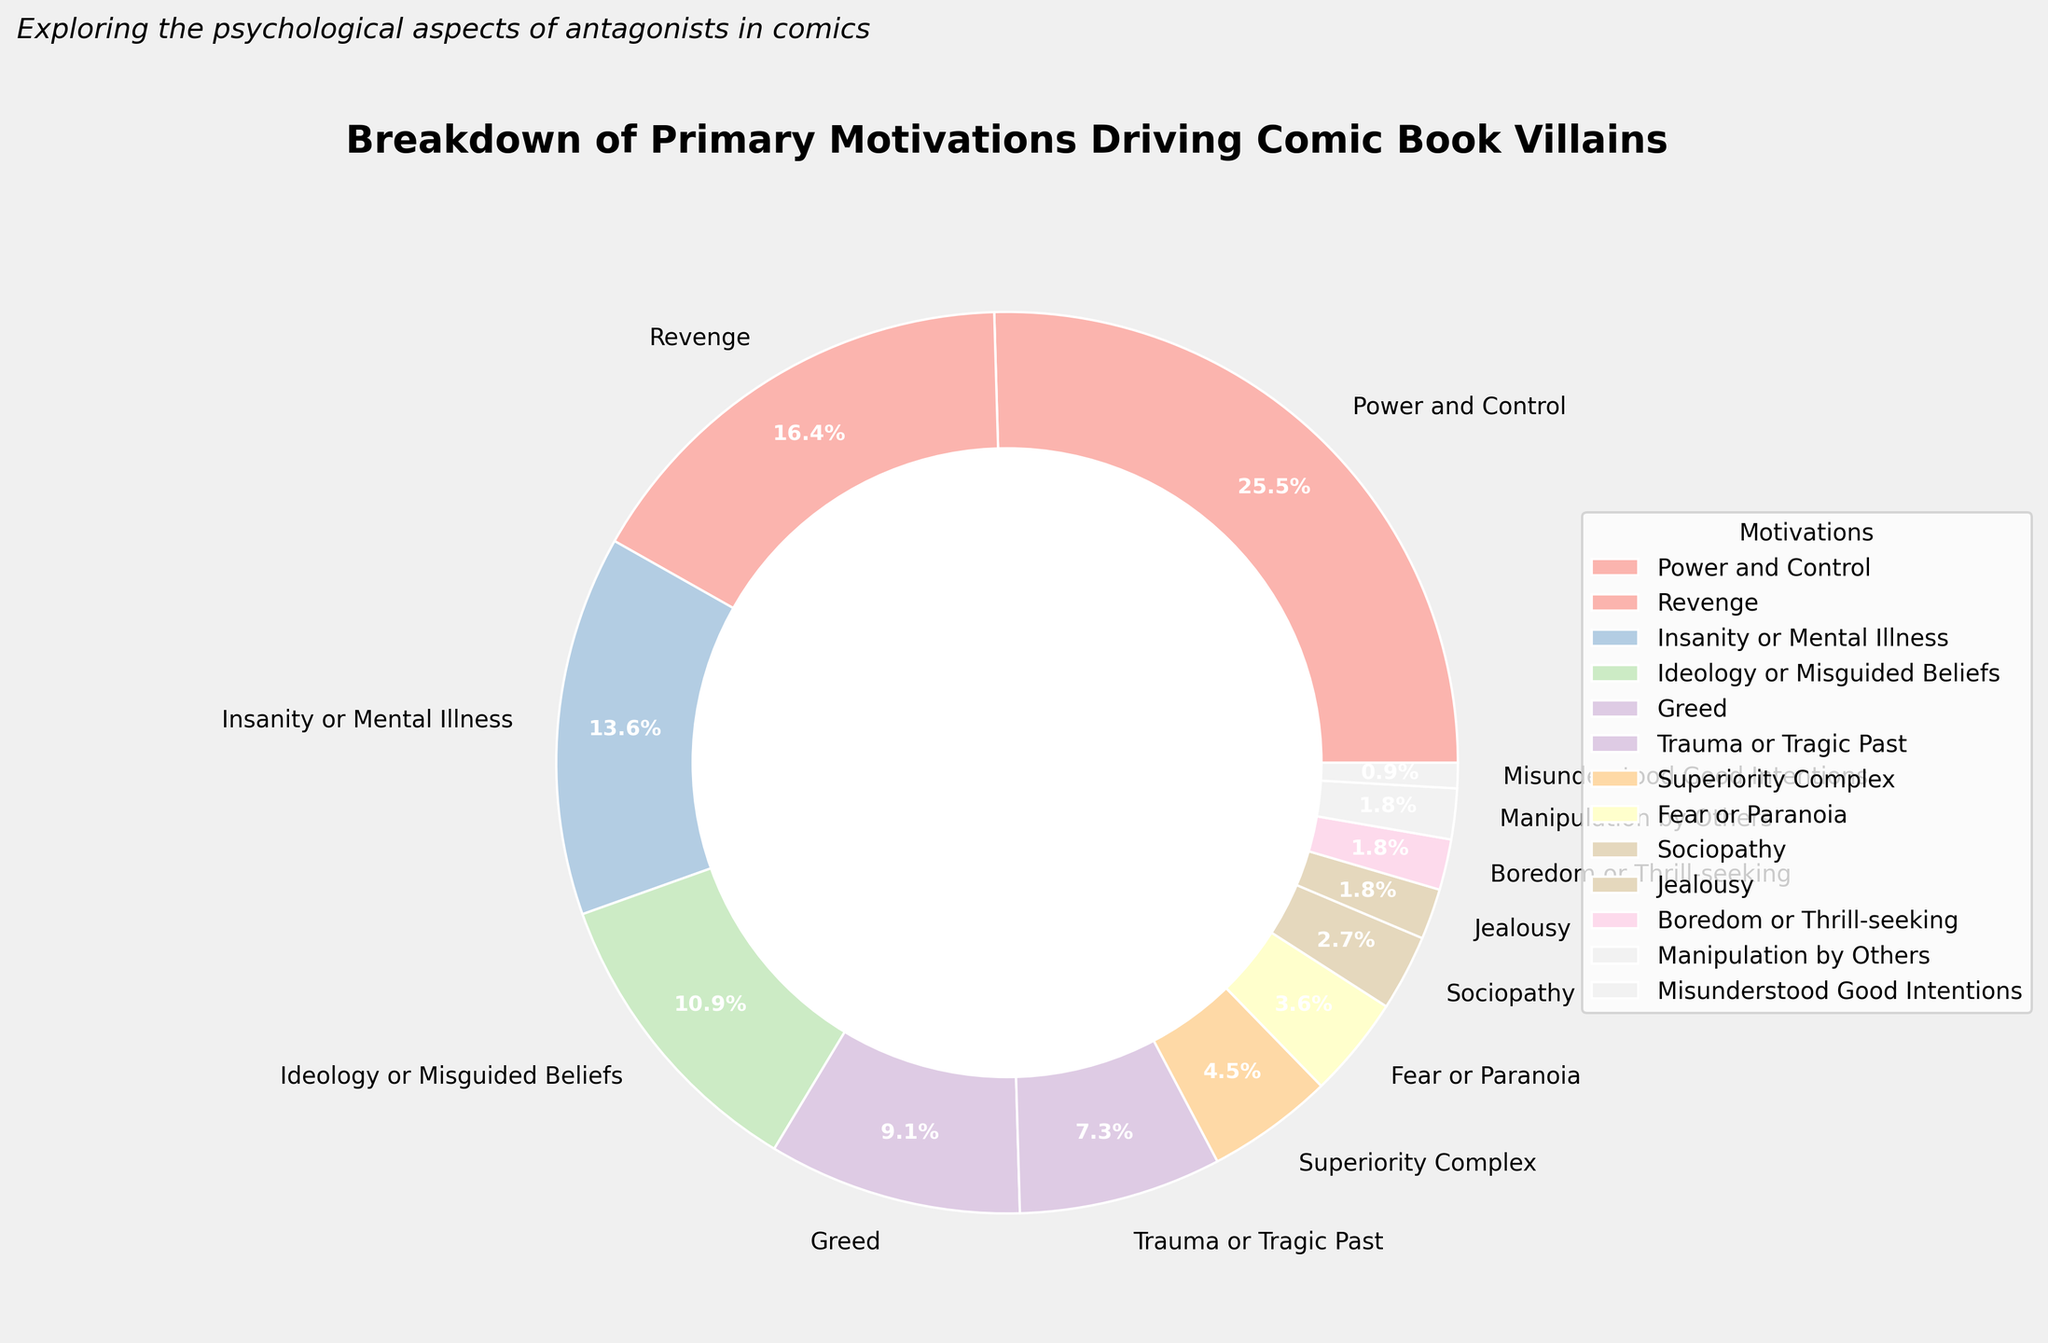What is the primary motivation driving comic book villains according to the chart? The largest segment in the pie chart represents "Power and Control," which accounts for 28% of the motivations.
Answer: Power and Control How does the percentage of villains driven by revenge compare to those driven by greed? The percentage for revenge is 18%, while for greed it is 10%. Revenge is greater.
Answer: Revenge is greater What is the combined percentage of villains driven by insanity or mental illness and those with a trauma or tragic past? Insanity or mental illness is 15%, and trauma or tragic past is 8%. Adding these together gives 15% + 8% = 23%.
Answer: 23% Between ideology or misguided beliefs and jealousy, which motivation is more common and by how much? Ideology or misguided beliefs is 12%, and jealousy is 2%. The difference is 12% - 2% = 10%.
Answer: Ideology or misguided beliefs by 10% Which motivations have a lower percentage than greed according to the figure? Greed accounts for 10%. The motivations with a lower percentage are trauma or tragic past (8%), superiority complex (5%), fear or paranoia (4%), sociopathy (3%), jealousy (2%), boredom or thrill-seeking (2%), manipulation by others (2%), and misunderstood good intentions (1%).
Answer: Trauma or Tragic Past, Superiority Complex, Fear or Paranoia, Sociopathy, Jealousy, Boredom or Thrill-seeking, Manipulation by Others, Misunderstood Good Intentions What percentage of villains are driven by fear or paranoia, sociopathy, and boredom or thrill-seeking combined? Fear or paranoia is 4%, sociopathy is 3%, boredom or thrill-seeking is 2%. Adding these together gives 4% + 3% + 2% = 9%.
Answer: 9% Which motivation has the smallest representation in the chart? The smallest segment in the pie chart is for "Misunderstood Good Intentions," which accounts for 1%.
Answer: Misunderstood Good Intentions Are there more villains motivated by power and control than by revenge and greed combined? Power and control is 28%, revenge is 18%, and greed is 10%. Together, revenge and greed add up to 18% + 10% = 28%, which is equal to power and control.
Answer: Equal What is the difference in percentage between villains motivated by ideology or misguided beliefs and those driven by superiority complex? Ideology or misguided beliefs account for 12%, while superiority complex accounts for 5%. The difference is 12% - 5% = 7%.
Answer: 7% How many motivations in the figure have a percentage representation of 5% or less? The motivations with 5% or less are superiority complex (5%), fear or paranoia (4%), sociopathy (3%), jealousy (2%), boredom or thrill-seeking (2%), manipulation by others (2%), and misunderstood good intentions (1%), which totals 7 motivations.
Answer: 7 